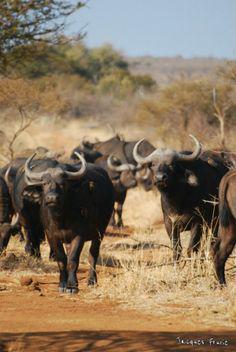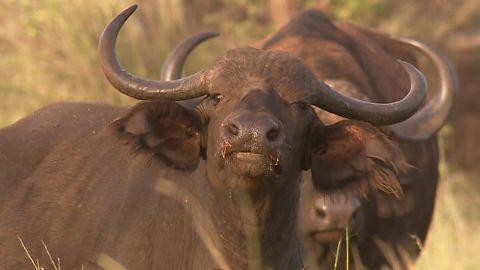The first image is the image on the left, the second image is the image on the right. Examine the images to the left and right. Is the description "The sky is visible in the left image." accurate? Answer yes or no. Yes. The first image is the image on the left, the second image is the image on the right. For the images displayed, is the sentence "In each image, at least one forward-facing water buffalo with raised head is prominent, and no image contains more than a dozen distinguishable buffalo." factually correct? Answer yes or no. Yes. 